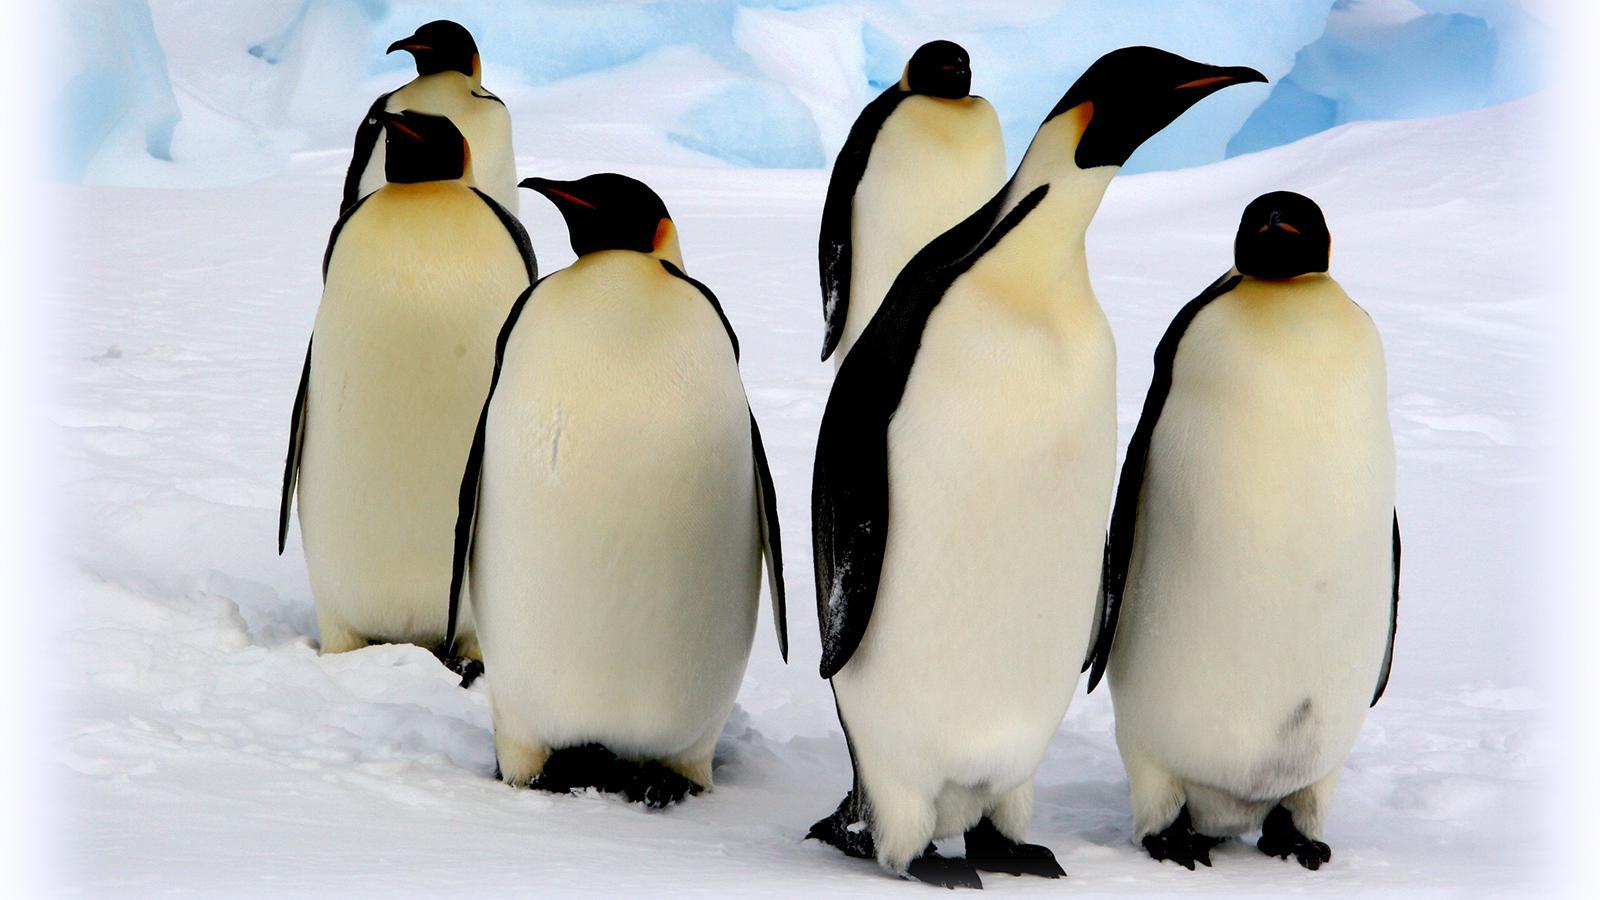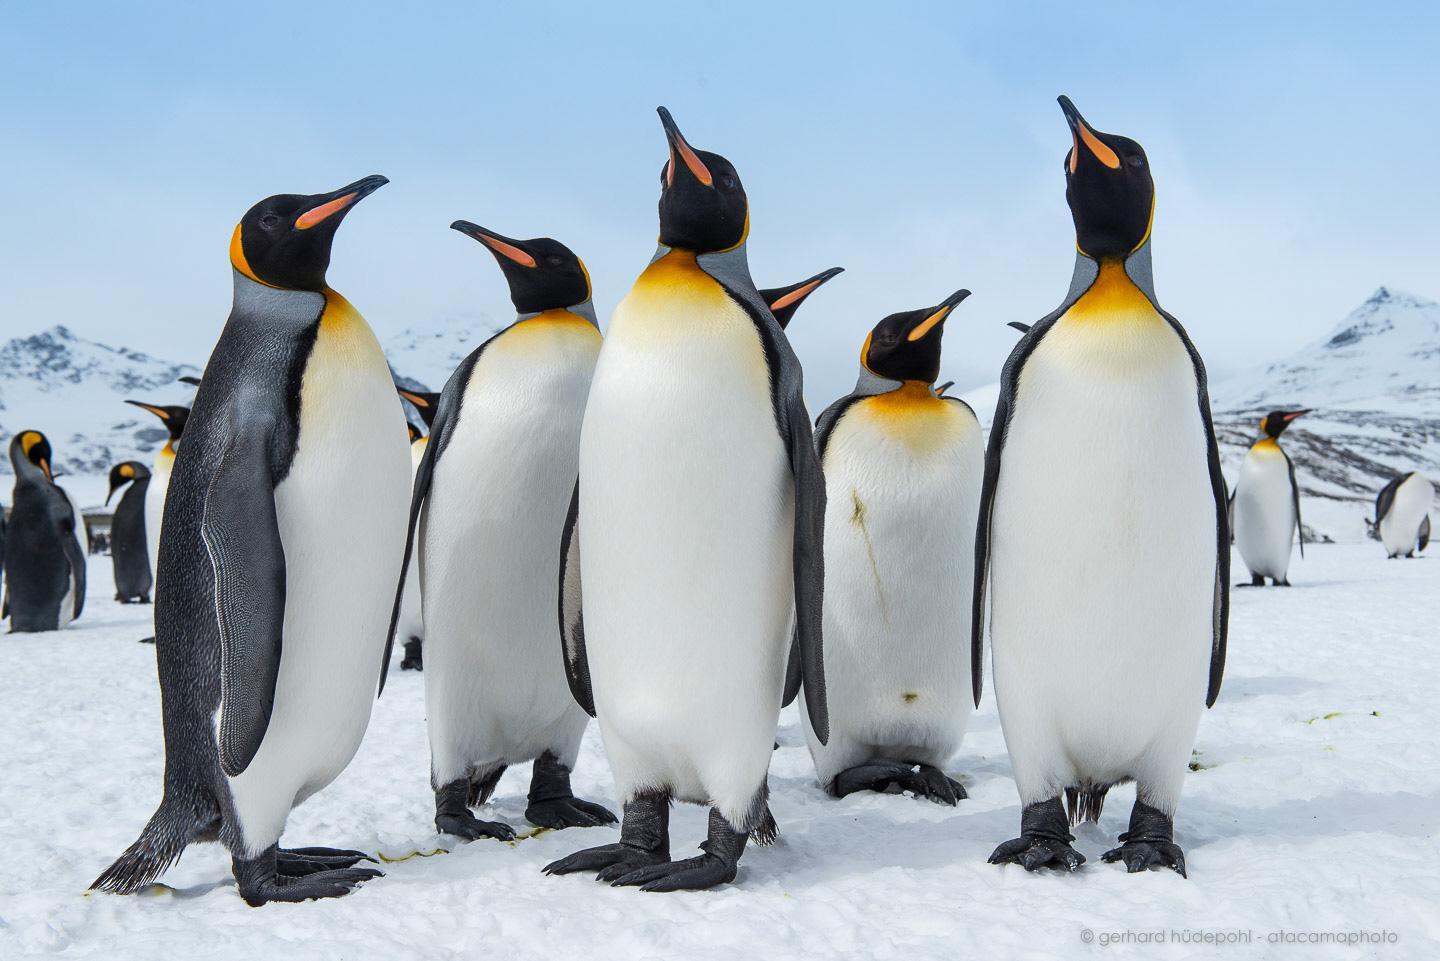The first image is the image on the left, the second image is the image on the right. Analyze the images presented: Is the assertion "There are no more than four penguins standing together in the image on the left." valid? Answer yes or no. No. The first image is the image on the left, the second image is the image on the right. For the images displayed, is the sentence "Left image contains multiple penguins with backs turned to the camera." factually correct? Answer yes or no. No. 